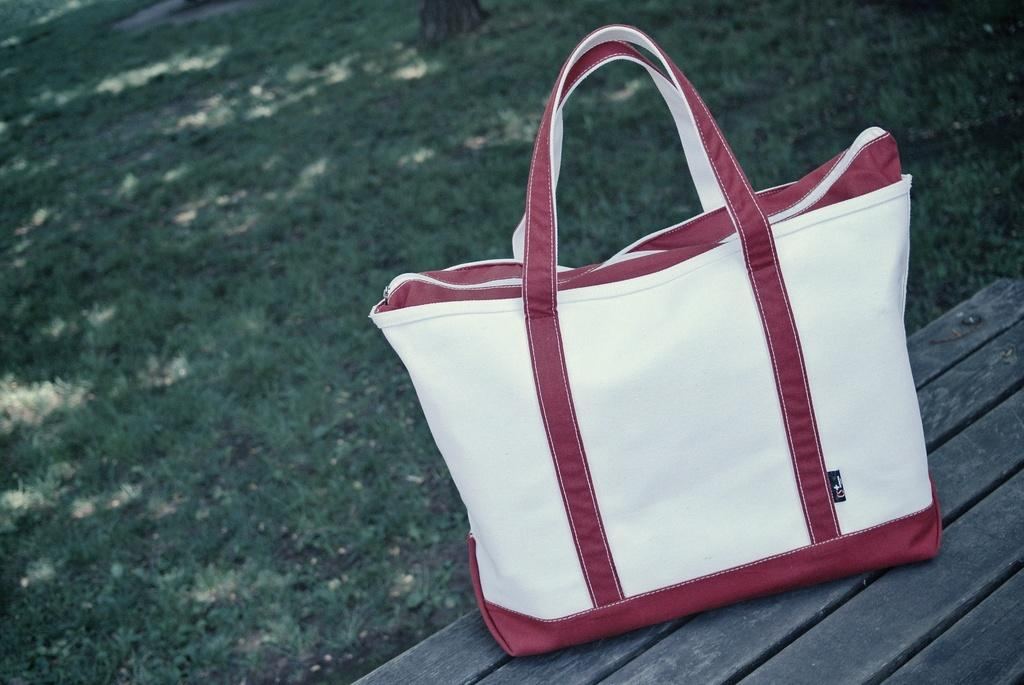What is the setting of the image? The image is of the outside of a house. What piece of furniture is visible in the image? There is a bench in the image. Is there anything placed on the bench? Yes, there is a bag on the bench. Can you tell me the name of the expert who designed the bag in the image? There is no expert mentioned in the image, nor is there any information about the bag's designer. 